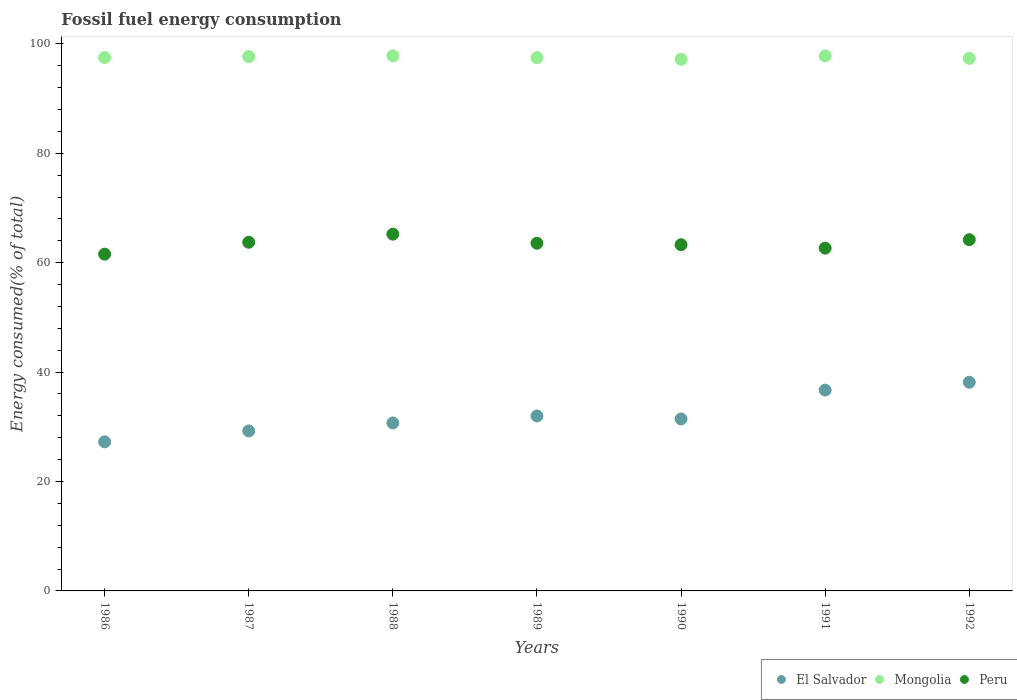How many different coloured dotlines are there?
Keep it short and to the point. 3. What is the percentage of energy consumed in El Salvador in 1988?
Offer a very short reply. 30.7. Across all years, what is the maximum percentage of energy consumed in El Salvador?
Provide a short and direct response. 38.14. Across all years, what is the minimum percentage of energy consumed in El Salvador?
Make the answer very short. 27.25. In which year was the percentage of energy consumed in Peru maximum?
Give a very brief answer. 1988. In which year was the percentage of energy consumed in Mongolia minimum?
Your response must be concise. 1990. What is the total percentage of energy consumed in El Salvador in the graph?
Your answer should be compact. 225.46. What is the difference between the percentage of energy consumed in Peru in 1986 and that in 1987?
Offer a terse response. -2.18. What is the difference between the percentage of energy consumed in El Salvador in 1991 and the percentage of energy consumed in Mongolia in 1989?
Offer a terse response. -60.77. What is the average percentage of energy consumed in El Salvador per year?
Make the answer very short. 32.21. In the year 1991, what is the difference between the percentage of energy consumed in Peru and percentage of energy consumed in El Salvador?
Offer a very short reply. 25.94. In how many years, is the percentage of energy consumed in Peru greater than 40 %?
Your answer should be very brief. 7. What is the ratio of the percentage of energy consumed in Peru in 1986 to that in 1990?
Give a very brief answer. 0.97. What is the difference between the highest and the second highest percentage of energy consumed in Peru?
Provide a succinct answer. 1.01. What is the difference between the highest and the lowest percentage of energy consumed in Peru?
Your answer should be very brief. 3.66. In how many years, is the percentage of energy consumed in El Salvador greater than the average percentage of energy consumed in El Salvador taken over all years?
Provide a short and direct response. 2. Is the sum of the percentage of energy consumed in El Salvador in 1988 and 1991 greater than the maximum percentage of energy consumed in Mongolia across all years?
Provide a succinct answer. No. How many dotlines are there?
Offer a terse response. 3. How many years are there in the graph?
Your response must be concise. 7. What is the difference between two consecutive major ticks on the Y-axis?
Your answer should be very brief. 20. Does the graph contain grids?
Keep it short and to the point. No. What is the title of the graph?
Offer a very short reply. Fossil fuel energy consumption. What is the label or title of the X-axis?
Provide a short and direct response. Years. What is the label or title of the Y-axis?
Your response must be concise. Energy consumed(% of total). What is the Energy consumed(% of total) of El Salvador in 1986?
Provide a succinct answer. 27.25. What is the Energy consumed(% of total) in Mongolia in 1986?
Keep it short and to the point. 97.5. What is the Energy consumed(% of total) of Peru in 1986?
Your response must be concise. 61.56. What is the Energy consumed(% of total) of El Salvador in 1987?
Your answer should be compact. 29.24. What is the Energy consumed(% of total) of Mongolia in 1987?
Your response must be concise. 97.67. What is the Energy consumed(% of total) in Peru in 1987?
Provide a short and direct response. 63.73. What is the Energy consumed(% of total) in El Salvador in 1988?
Give a very brief answer. 30.7. What is the Energy consumed(% of total) in Mongolia in 1988?
Keep it short and to the point. 97.8. What is the Energy consumed(% of total) in Peru in 1988?
Offer a very short reply. 65.22. What is the Energy consumed(% of total) in El Salvador in 1989?
Your answer should be compact. 31.98. What is the Energy consumed(% of total) in Mongolia in 1989?
Provide a succinct answer. 97.48. What is the Energy consumed(% of total) of Peru in 1989?
Make the answer very short. 63.55. What is the Energy consumed(% of total) of El Salvador in 1990?
Give a very brief answer. 31.44. What is the Energy consumed(% of total) of Mongolia in 1990?
Offer a terse response. 97.17. What is the Energy consumed(% of total) in Peru in 1990?
Give a very brief answer. 63.28. What is the Energy consumed(% of total) of El Salvador in 1991?
Give a very brief answer. 36.71. What is the Energy consumed(% of total) of Mongolia in 1991?
Provide a short and direct response. 97.8. What is the Energy consumed(% of total) of Peru in 1991?
Give a very brief answer. 62.65. What is the Energy consumed(% of total) in El Salvador in 1992?
Offer a very short reply. 38.14. What is the Energy consumed(% of total) of Mongolia in 1992?
Provide a short and direct response. 97.35. What is the Energy consumed(% of total) of Peru in 1992?
Ensure brevity in your answer.  64.2. Across all years, what is the maximum Energy consumed(% of total) in El Salvador?
Your answer should be very brief. 38.14. Across all years, what is the maximum Energy consumed(% of total) in Mongolia?
Give a very brief answer. 97.8. Across all years, what is the maximum Energy consumed(% of total) in Peru?
Offer a very short reply. 65.22. Across all years, what is the minimum Energy consumed(% of total) in El Salvador?
Your response must be concise. 27.25. Across all years, what is the minimum Energy consumed(% of total) of Mongolia?
Offer a very short reply. 97.17. Across all years, what is the minimum Energy consumed(% of total) in Peru?
Offer a terse response. 61.56. What is the total Energy consumed(% of total) of El Salvador in the graph?
Offer a very short reply. 225.46. What is the total Energy consumed(% of total) of Mongolia in the graph?
Make the answer very short. 682.76. What is the total Energy consumed(% of total) in Peru in the graph?
Offer a terse response. 444.19. What is the difference between the Energy consumed(% of total) of El Salvador in 1986 and that in 1987?
Your response must be concise. -1.99. What is the difference between the Energy consumed(% of total) of Mongolia in 1986 and that in 1987?
Provide a short and direct response. -0.17. What is the difference between the Energy consumed(% of total) in Peru in 1986 and that in 1987?
Your response must be concise. -2.18. What is the difference between the Energy consumed(% of total) of El Salvador in 1986 and that in 1988?
Give a very brief answer. -3.46. What is the difference between the Energy consumed(% of total) of Mongolia in 1986 and that in 1988?
Keep it short and to the point. -0.3. What is the difference between the Energy consumed(% of total) of Peru in 1986 and that in 1988?
Your answer should be compact. -3.66. What is the difference between the Energy consumed(% of total) of El Salvador in 1986 and that in 1989?
Offer a terse response. -4.73. What is the difference between the Energy consumed(% of total) of Mongolia in 1986 and that in 1989?
Ensure brevity in your answer.  0.02. What is the difference between the Energy consumed(% of total) in Peru in 1986 and that in 1989?
Offer a very short reply. -2. What is the difference between the Energy consumed(% of total) in El Salvador in 1986 and that in 1990?
Keep it short and to the point. -4.19. What is the difference between the Energy consumed(% of total) of Mongolia in 1986 and that in 1990?
Provide a succinct answer. 0.32. What is the difference between the Energy consumed(% of total) in Peru in 1986 and that in 1990?
Offer a very short reply. -1.72. What is the difference between the Energy consumed(% of total) in El Salvador in 1986 and that in 1991?
Your answer should be very brief. -9.46. What is the difference between the Energy consumed(% of total) of Mongolia in 1986 and that in 1991?
Offer a very short reply. -0.3. What is the difference between the Energy consumed(% of total) in Peru in 1986 and that in 1991?
Your response must be concise. -1.1. What is the difference between the Energy consumed(% of total) of El Salvador in 1986 and that in 1992?
Your response must be concise. -10.89. What is the difference between the Energy consumed(% of total) of Mongolia in 1986 and that in 1992?
Keep it short and to the point. 0.15. What is the difference between the Energy consumed(% of total) in Peru in 1986 and that in 1992?
Your response must be concise. -2.65. What is the difference between the Energy consumed(% of total) in El Salvador in 1987 and that in 1988?
Your response must be concise. -1.46. What is the difference between the Energy consumed(% of total) of Mongolia in 1987 and that in 1988?
Provide a short and direct response. -0.13. What is the difference between the Energy consumed(% of total) in Peru in 1987 and that in 1988?
Your answer should be compact. -1.48. What is the difference between the Energy consumed(% of total) in El Salvador in 1987 and that in 1989?
Make the answer very short. -2.74. What is the difference between the Energy consumed(% of total) of Mongolia in 1987 and that in 1989?
Provide a succinct answer. 0.19. What is the difference between the Energy consumed(% of total) of Peru in 1987 and that in 1989?
Provide a succinct answer. 0.18. What is the difference between the Energy consumed(% of total) of El Salvador in 1987 and that in 1990?
Make the answer very short. -2.19. What is the difference between the Energy consumed(% of total) of Mongolia in 1987 and that in 1990?
Ensure brevity in your answer.  0.5. What is the difference between the Energy consumed(% of total) of Peru in 1987 and that in 1990?
Offer a terse response. 0.45. What is the difference between the Energy consumed(% of total) of El Salvador in 1987 and that in 1991?
Your answer should be compact. -7.47. What is the difference between the Energy consumed(% of total) in Mongolia in 1987 and that in 1991?
Your answer should be compact. -0.13. What is the difference between the Energy consumed(% of total) in Peru in 1987 and that in 1991?
Your response must be concise. 1.08. What is the difference between the Energy consumed(% of total) of El Salvador in 1987 and that in 1992?
Your answer should be very brief. -8.9. What is the difference between the Energy consumed(% of total) of Mongolia in 1987 and that in 1992?
Your answer should be compact. 0.32. What is the difference between the Energy consumed(% of total) in Peru in 1987 and that in 1992?
Offer a very short reply. -0.47. What is the difference between the Energy consumed(% of total) in El Salvador in 1988 and that in 1989?
Provide a succinct answer. -1.27. What is the difference between the Energy consumed(% of total) of Mongolia in 1988 and that in 1989?
Offer a terse response. 0.32. What is the difference between the Energy consumed(% of total) in Peru in 1988 and that in 1989?
Keep it short and to the point. 1.66. What is the difference between the Energy consumed(% of total) in El Salvador in 1988 and that in 1990?
Your answer should be compact. -0.73. What is the difference between the Energy consumed(% of total) of Mongolia in 1988 and that in 1990?
Offer a terse response. 0.63. What is the difference between the Energy consumed(% of total) of Peru in 1988 and that in 1990?
Offer a terse response. 1.94. What is the difference between the Energy consumed(% of total) of El Salvador in 1988 and that in 1991?
Make the answer very short. -6. What is the difference between the Energy consumed(% of total) in Mongolia in 1988 and that in 1991?
Give a very brief answer. 0. What is the difference between the Energy consumed(% of total) of Peru in 1988 and that in 1991?
Your answer should be very brief. 2.56. What is the difference between the Energy consumed(% of total) of El Salvador in 1988 and that in 1992?
Provide a succinct answer. -7.44. What is the difference between the Energy consumed(% of total) of Mongolia in 1988 and that in 1992?
Offer a very short reply. 0.45. What is the difference between the Energy consumed(% of total) of Peru in 1988 and that in 1992?
Offer a very short reply. 1.01. What is the difference between the Energy consumed(% of total) in El Salvador in 1989 and that in 1990?
Ensure brevity in your answer.  0.54. What is the difference between the Energy consumed(% of total) in Mongolia in 1989 and that in 1990?
Offer a terse response. 0.31. What is the difference between the Energy consumed(% of total) in Peru in 1989 and that in 1990?
Offer a very short reply. 0.27. What is the difference between the Energy consumed(% of total) of El Salvador in 1989 and that in 1991?
Your response must be concise. -4.73. What is the difference between the Energy consumed(% of total) of Mongolia in 1989 and that in 1991?
Provide a short and direct response. -0.32. What is the difference between the Energy consumed(% of total) in Peru in 1989 and that in 1991?
Ensure brevity in your answer.  0.9. What is the difference between the Energy consumed(% of total) of El Salvador in 1989 and that in 1992?
Keep it short and to the point. -6.16. What is the difference between the Energy consumed(% of total) in Mongolia in 1989 and that in 1992?
Give a very brief answer. 0.13. What is the difference between the Energy consumed(% of total) in Peru in 1989 and that in 1992?
Make the answer very short. -0.65. What is the difference between the Energy consumed(% of total) of El Salvador in 1990 and that in 1991?
Offer a terse response. -5.27. What is the difference between the Energy consumed(% of total) in Mongolia in 1990 and that in 1991?
Make the answer very short. -0.63. What is the difference between the Energy consumed(% of total) of Peru in 1990 and that in 1991?
Offer a very short reply. 0.63. What is the difference between the Energy consumed(% of total) of El Salvador in 1990 and that in 1992?
Ensure brevity in your answer.  -6.7. What is the difference between the Energy consumed(% of total) in Mongolia in 1990 and that in 1992?
Keep it short and to the point. -0.18. What is the difference between the Energy consumed(% of total) of Peru in 1990 and that in 1992?
Offer a very short reply. -0.92. What is the difference between the Energy consumed(% of total) in El Salvador in 1991 and that in 1992?
Your answer should be very brief. -1.43. What is the difference between the Energy consumed(% of total) of Mongolia in 1991 and that in 1992?
Provide a succinct answer. 0.45. What is the difference between the Energy consumed(% of total) in Peru in 1991 and that in 1992?
Your answer should be very brief. -1.55. What is the difference between the Energy consumed(% of total) in El Salvador in 1986 and the Energy consumed(% of total) in Mongolia in 1987?
Your answer should be very brief. -70.42. What is the difference between the Energy consumed(% of total) in El Salvador in 1986 and the Energy consumed(% of total) in Peru in 1987?
Your answer should be very brief. -36.48. What is the difference between the Energy consumed(% of total) of Mongolia in 1986 and the Energy consumed(% of total) of Peru in 1987?
Make the answer very short. 33.76. What is the difference between the Energy consumed(% of total) of El Salvador in 1986 and the Energy consumed(% of total) of Mongolia in 1988?
Keep it short and to the point. -70.55. What is the difference between the Energy consumed(% of total) of El Salvador in 1986 and the Energy consumed(% of total) of Peru in 1988?
Offer a very short reply. -37.97. What is the difference between the Energy consumed(% of total) of Mongolia in 1986 and the Energy consumed(% of total) of Peru in 1988?
Ensure brevity in your answer.  32.28. What is the difference between the Energy consumed(% of total) of El Salvador in 1986 and the Energy consumed(% of total) of Mongolia in 1989?
Offer a terse response. -70.23. What is the difference between the Energy consumed(% of total) of El Salvador in 1986 and the Energy consumed(% of total) of Peru in 1989?
Make the answer very short. -36.3. What is the difference between the Energy consumed(% of total) of Mongolia in 1986 and the Energy consumed(% of total) of Peru in 1989?
Ensure brevity in your answer.  33.94. What is the difference between the Energy consumed(% of total) in El Salvador in 1986 and the Energy consumed(% of total) in Mongolia in 1990?
Ensure brevity in your answer.  -69.92. What is the difference between the Energy consumed(% of total) in El Salvador in 1986 and the Energy consumed(% of total) in Peru in 1990?
Ensure brevity in your answer.  -36.03. What is the difference between the Energy consumed(% of total) in Mongolia in 1986 and the Energy consumed(% of total) in Peru in 1990?
Keep it short and to the point. 34.22. What is the difference between the Energy consumed(% of total) in El Salvador in 1986 and the Energy consumed(% of total) in Mongolia in 1991?
Provide a succinct answer. -70.55. What is the difference between the Energy consumed(% of total) of El Salvador in 1986 and the Energy consumed(% of total) of Peru in 1991?
Provide a succinct answer. -35.4. What is the difference between the Energy consumed(% of total) in Mongolia in 1986 and the Energy consumed(% of total) in Peru in 1991?
Keep it short and to the point. 34.84. What is the difference between the Energy consumed(% of total) of El Salvador in 1986 and the Energy consumed(% of total) of Mongolia in 1992?
Ensure brevity in your answer.  -70.1. What is the difference between the Energy consumed(% of total) in El Salvador in 1986 and the Energy consumed(% of total) in Peru in 1992?
Give a very brief answer. -36.96. What is the difference between the Energy consumed(% of total) in Mongolia in 1986 and the Energy consumed(% of total) in Peru in 1992?
Offer a terse response. 33.29. What is the difference between the Energy consumed(% of total) in El Salvador in 1987 and the Energy consumed(% of total) in Mongolia in 1988?
Your answer should be compact. -68.56. What is the difference between the Energy consumed(% of total) in El Salvador in 1987 and the Energy consumed(% of total) in Peru in 1988?
Offer a very short reply. -35.97. What is the difference between the Energy consumed(% of total) of Mongolia in 1987 and the Energy consumed(% of total) of Peru in 1988?
Your response must be concise. 32.45. What is the difference between the Energy consumed(% of total) of El Salvador in 1987 and the Energy consumed(% of total) of Mongolia in 1989?
Provide a short and direct response. -68.24. What is the difference between the Energy consumed(% of total) in El Salvador in 1987 and the Energy consumed(% of total) in Peru in 1989?
Make the answer very short. -34.31. What is the difference between the Energy consumed(% of total) in Mongolia in 1987 and the Energy consumed(% of total) in Peru in 1989?
Provide a succinct answer. 34.11. What is the difference between the Energy consumed(% of total) of El Salvador in 1987 and the Energy consumed(% of total) of Mongolia in 1990?
Your answer should be compact. -67.93. What is the difference between the Energy consumed(% of total) in El Salvador in 1987 and the Energy consumed(% of total) in Peru in 1990?
Your answer should be compact. -34.04. What is the difference between the Energy consumed(% of total) of Mongolia in 1987 and the Energy consumed(% of total) of Peru in 1990?
Offer a terse response. 34.39. What is the difference between the Energy consumed(% of total) of El Salvador in 1987 and the Energy consumed(% of total) of Mongolia in 1991?
Your response must be concise. -68.56. What is the difference between the Energy consumed(% of total) in El Salvador in 1987 and the Energy consumed(% of total) in Peru in 1991?
Ensure brevity in your answer.  -33.41. What is the difference between the Energy consumed(% of total) of Mongolia in 1987 and the Energy consumed(% of total) of Peru in 1991?
Your answer should be compact. 35.02. What is the difference between the Energy consumed(% of total) in El Salvador in 1987 and the Energy consumed(% of total) in Mongolia in 1992?
Offer a very short reply. -68.11. What is the difference between the Energy consumed(% of total) in El Salvador in 1987 and the Energy consumed(% of total) in Peru in 1992?
Ensure brevity in your answer.  -34.96. What is the difference between the Energy consumed(% of total) in Mongolia in 1987 and the Energy consumed(% of total) in Peru in 1992?
Ensure brevity in your answer.  33.46. What is the difference between the Energy consumed(% of total) of El Salvador in 1988 and the Energy consumed(% of total) of Mongolia in 1989?
Your answer should be very brief. -66.78. What is the difference between the Energy consumed(% of total) in El Salvador in 1988 and the Energy consumed(% of total) in Peru in 1989?
Make the answer very short. -32.85. What is the difference between the Energy consumed(% of total) in Mongolia in 1988 and the Energy consumed(% of total) in Peru in 1989?
Provide a succinct answer. 34.25. What is the difference between the Energy consumed(% of total) of El Salvador in 1988 and the Energy consumed(% of total) of Mongolia in 1990?
Provide a short and direct response. -66.47. What is the difference between the Energy consumed(% of total) of El Salvador in 1988 and the Energy consumed(% of total) of Peru in 1990?
Provide a succinct answer. -32.58. What is the difference between the Energy consumed(% of total) of Mongolia in 1988 and the Energy consumed(% of total) of Peru in 1990?
Keep it short and to the point. 34.52. What is the difference between the Energy consumed(% of total) of El Salvador in 1988 and the Energy consumed(% of total) of Mongolia in 1991?
Provide a succinct answer. -67.09. What is the difference between the Energy consumed(% of total) in El Salvador in 1988 and the Energy consumed(% of total) in Peru in 1991?
Ensure brevity in your answer.  -31.95. What is the difference between the Energy consumed(% of total) of Mongolia in 1988 and the Energy consumed(% of total) of Peru in 1991?
Offer a terse response. 35.15. What is the difference between the Energy consumed(% of total) in El Salvador in 1988 and the Energy consumed(% of total) in Mongolia in 1992?
Your response must be concise. -66.65. What is the difference between the Energy consumed(% of total) in El Salvador in 1988 and the Energy consumed(% of total) in Peru in 1992?
Keep it short and to the point. -33.5. What is the difference between the Energy consumed(% of total) of Mongolia in 1988 and the Energy consumed(% of total) of Peru in 1992?
Ensure brevity in your answer.  33.59. What is the difference between the Energy consumed(% of total) of El Salvador in 1989 and the Energy consumed(% of total) of Mongolia in 1990?
Keep it short and to the point. -65.19. What is the difference between the Energy consumed(% of total) of El Salvador in 1989 and the Energy consumed(% of total) of Peru in 1990?
Your answer should be very brief. -31.3. What is the difference between the Energy consumed(% of total) of Mongolia in 1989 and the Energy consumed(% of total) of Peru in 1990?
Provide a short and direct response. 34.2. What is the difference between the Energy consumed(% of total) of El Salvador in 1989 and the Energy consumed(% of total) of Mongolia in 1991?
Your answer should be compact. -65.82. What is the difference between the Energy consumed(% of total) in El Salvador in 1989 and the Energy consumed(% of total) in Peru in 1991?
Provide a succinct answer. -30.68. What is the difference between the Energy consumed(% of total) in Mongolia in 1989 and the Energy consumed(% of total) in Peru in 1991?
Keep it short and to the point. 34.83. What is the difference between the Energy consumed(% of total) in El Salvador in 1989 and the Energy consumed(% of total) in Mongolia in 1992?
Your response must be concise. -65.37. What is the difference between the Energy consumed(% of total) of El Salvador in 1989 and the Energy consumed(% of total) of Peru in 1992?
Make the answer very short. -32.23. What is the difference between the Energy consumed(% of total) of Mongolia in 1989 and the Energy consumed(% of total) of Peru in 1992?
Make the answer very short. 33.27. What is the difference between the Energy consumed(% of total) of El Salvador in 1990 and the Energy consumed(% of total) of Mongolia in 1991?
Give a very brief answer. -66.36. What is the difference between the Energy consumed(% of total) in El Salvador in 1990 and the Energy consumed(% of total) in Peru in 1991?
Provide a succinct answer. -31.22. What is the difference between the Energy consumed(% of total) of Mongolia in 1990 and the Energy consumed(% of total) of Peru in 1991?
Offer a terse response. 34.52. What is the difference between the Energy consumed(% of total) in El Salvador in 1990 and the Energy consumed(% of total) in Mongolia in 1992?
Keep it short and to the point. -65.91. What is the difference between the Energy consumed(% of total) in El Salvador in 1990 and the Energy consumed(% of total) in Peru in 1992?
Your response must be concise. -32.77. What is the difference between the Energy consumed(% of total) of Mongolia in 1990 and the Energy consumed(% of total) of Peru in 1992?
Offer a terse response. 32.97. What is the difference between the Energy consumed(% of total) of El Salvador in 1991 and the Energy consumed(% of total) of Mongolia in 1992?
Keep it short and to the point. -60.64. What is the difference between the Energy consumed(% of total) of El Salvador in 1991 and the Energy consumed(% of total) of Peru in 1992?
Keep it short and to the point. -27.5. What is the difference between the Energy consumed(% of total) of Mongolia in 1991 and the Energy consumed(% of total) of Peru in 1992?
Provide a succinct answer. 33.59. What is the average Energy consumed(% of total) of El Salvador per year?
Your answer should be compact. 32.21. What is the average Energy consumed(% of total) in Mongolia per year?
Make the answer very short. 97.54. What is the average Energy consumed(% of total) in Peru per year?
Ensure brevity in your answer.  63.46. In the year 1986, what is the difference between the Energy consumed(% of total) in El Salvador and Energy consumed(% of total) in Mongolia?
Ensure brevity in your answer.  -70.25. In the year 1986, what is the difference between the Energy consumed(% of total) of El Salvador and Energy consumed(% of total) of Peru?
Ensure brevity in your answer.  -34.31. In the year 1986, what is the difference between the Energy consumed(% of total) in Mongolia and Energy consumed(% of total) in Peru?
Provide a succinct answer. 35.94. In the year 1987, what is the difference between the Energy consumed(% of total) of El Salvador and Energy consumed(% of total) of Mongolia?
Keep it short and to the point. -68.43. In the year 1987, what is the difference between the Energy consumed(% of total) of El Salvador and Energy consumed(% of total) of Peru?
Keep it short and to the point. -34.49. In the year 1987, what is the difference between the Energy consumed(% of total) in Mongolia and Energy consumed(% of total) in Peru?
Offer a terse response. 33.94. In the year 1988, what is the difference between the Energy consumed(% of total) of El Salvador and Energy consumed(% of total) of Mongolia?
Give a very brief answer. -67.1. In the year 1988, what is the difference between the Energy consumed(% of total) of El Salvador and Energy consumed(% of total) of Peru?
Provide a succinct answer. -34.51. In the year 1988, what is the difference between the Energy consumed(% of total) in Mongolia and Energy consumed(% of total) in Peru?
Provide a succinct answer. 32.58. In the year 1989, what is the difference between the Energy consumed(% of total) in El Salvador and Energy consumed(% of total) in Mongolia?
Provide a short and direct response. -65.5. In the year 1989, what is the difference between the Energy consumed(% of total) in El Salvador and Energy consumed(% of total) in Peru?
Provide a short and direct response. -31.58. In the year 1989, what is the difference between the Energy consumed(% of total) in Mongolia and Energy consumed(% of total) in Peru?
Provide a succinct answer. 33.93. In the year 1990, what is the difference between the Energy consumed(% of total) of El Salvador and Energy consumed(% of total) of Mongolia?
Provide a short and direct response. -65.74. In the year 1990, what is the difference between the Energy consumed(% of total) of El Salvador and Energy consumed(% of total) of Peru?
Offer a very short reply. -31.84. In the year 1990, what is the difference between the Energy consumed(% of total) of Mongolia and Energy consumed(% of total) of Peru?
Offer a very short reply. 33.89. In the year 1991, what is the difference between the Energy consumed(% of total) in El Salvador and Energy consumed(% of total) in Mongolia?
Give a very brief answer. -61.09. In the year 1991, what is the difference between the Energy consumed(% of total) of El Salvador and Energy consumed(% of total) of Peru?
Offer a terse response. -25.94. In the year 1991, what is the difference between the Energy consumed(% of total) in Mongolia and Energy consumed(% of total) in Peru?
Your response must be concise. 35.15. In the year 1992, what is the difference between the Energy consumed(% of total) of El Salvador and Energy consumed(% of total) of Mongolia?
Your response must be concise. -59.21. In the year 1992, what is the difference between the Energy consumed(% of total) of El Salvador and Energy consumed(% of total) of Peru?
Offer a very short reply. -26.06. In the year 1992, what is the difference between the Energy consumed(% of total) of Mongolia and Energy consumed(% of total) of Peru?
Make the answer very short. 33.14. What is the ratio of the Energy consumed(% of total) of El Salvador in 1986 to that in 1987?
Keep it short and to the point. 0.93. What is the ratio of the Energy consumed(% of total) in Mongolia in 1986 to that in 1987?
Offer a very short reply. 1. What is the ratio of the Energy consumed(% of total) of Peru in 1986 to that in 1987?
Your response must be concise. 0.97. What is the ratio of the Energy consumed(% of total) of El Salvador in 1986 to that in 1988?
Your response must be concise. 0.89. What is the ratio of the Energy consumed(% of total) of Peru in 1986 to that in 1988?
Your response must be concise. 0.94. What is the ratio of the Energy consumed(% of total) of El Salvador in 1986 to that in 1989?
Offer a terse response. 0.85. What is the ratio of the Energy consumed(% of total) of Peru in 1986 to that in 1989?
Offer a terse response. 0.97. What is the ratio of the Energy consumed(% of total) of El Salvador in 1986 to that in 1990?
Your answer should be very brief. 0.87. What is the ratio of the Energy consumed(% of total) of Peru in 1986 to that in 1990?
Provide a succinct answer. 0.97. What is the ratio of the Energy consumed(% of total) in El Salvador in 1986 to that in 1991?
Your answer should be very brief. 0.74. What is the ratio of the Energy consumed(% of total) in Mongolia in 1986 to that in 1991?
Offer a terse response. 1. What is the ratio of the Energy consumed(% of total) in Peru in 1986 to that in 1991?
Offer a very short reply. 0.98. What is the ratio of the Energy consumed(% of total) of El Salvador in 1986 to that in 1992?
Keep it short and to the point. 0.71. What is the ratio of the Energy consumed(% of total) of Mongolia in 1986 to that in 1992?
Make the answer very short. 1. What is the ratio of the Energy consumed(% of total) of Peru in 1986 to that in 1992?
Provide a short and direct response. 0.96. What is the ratio of the Energy consumed(% of total) in El Salvador in 1987 to that in 1988?
Provide a succinct answer. 0.95. What is the ratio of the Energy consumed(% of total) of Mongolia in 1987 to that in 1988?
Provide a short and direct response. 1. What is the ratio of the Energy consumed(% of total) in Peru in 1987 to that in 1988?
Ensure brevity in your answer.  0.98. What is the ratio of the Energy consumed(% of total) of El Salvador in 1987 to that in 1989?
Ensure brevity in your answer.  0.91. What is the ratio of the Energy consumed(% of total) of Peru in 1987 to that in 1989?
Keep it short and to the point. 1. What is the ratio of the Energy consumed(% of total) of El Salvador in 1987 to that in 1990?
Give a very brief answer. 0.93. What is the ratio of the Energy consumed(% of total) of Mongolia in 1987 to that in 1990?
Offer a terse response. 1.01. What is the ratio of the Energy consumed(% of total) in Peru in 1987 to that in 1990?
Provide a short and direct response. 1.01. What is the ratio of the Energy consumed(% of total) in El Salvador in 1987 to that in 1991?
Keep it short and to the point. 0.8. What is the ratio of the Energy consumed(% of total) of Peru in 1987 to that in 1991?
Provide a short and direct response. 1.02. What is the ratio of the Energy consumed(% of total) of El Salvador in 1987 to that in 1992?
Provide a succinct answer. 0.77. What is the ratio of the Energy consumed(% of total) of El Salvador in 1988 to that in 1989?
Ensure brevity in your answer.  0.96. What is the ratio of the Energy consumed(% of total) of Peru in 1988 to that in 1989?
Keep it short and to the point. 1.03. What is the ratio of the Energy consumed(% of total) of El Salvador in 1988 to that in 1990?
Your answer should be very brief. 0.98. What is the ratio of the Energy consumed(% of total) in Peru in 1988 to that in 1990?
Ensure brevity in your answer.  1.03. What is the ratio of the Energy consumed(% of total) in El Salvador in 1988 to that in 1991?
Offer a terse response. 0.84. What is the ratio of the Energy consumed(% of total) in Mongolia in 1988 to that in 1991?
Provide a short and direct response. 1. What is the ratio of the Energy consumed(% of total) in Peru in 1988 to that in 1991?
Offer a terse response. 1.04. What is the ratio of the Energy consumed(% of total) of El Salvador in 1988 to that in 1992?
Keep it short and to the point. 0.81. What is the ratio of the Energy consumed(% of total) in Peru in 1988 to that in 1992?
Your answer should be compact. 1.02. What is the ratio of the Energy consumed(% of total) in El Salvador in 1989 to that in 1990?
Give a very brief answer. 1.02. What is the ratio of the Energy consumed(% of total) of Mongolia in 1989 to that in 1990?
Ensure brevity in your answer.  1. What is the ratio of the Energy consumed(% of total) in El Salvador in 1989 to that in 1991?
Ensure brevity in your answer.  0.87. What is the ratio of the Energy consumed(% of total) of Mongolia in 1989 to that in 1991?
Ensure brevity in your answer.  1. What is the ratio of the Energy consumed(% of total) of Peru in 1989 to that in 1991?
Keep it short and to the point. 1.01. What is the ratio of the Energy consumed(% of total) of El Salvador in 1989 to that in 1992?
Offer a terse response. 0.84. What is the ratio of the Energy consumed(% of total) of Peru in 1989 to that in 1992?
Your answer should be compact. 0.99. What is the ratio of the Energy consumed(% of total) in El Salvador in 1990 to that in 1991?
Offer a very short reply. 0.86. What is the ratio of the Energy consumed(% of total) in Mongolia in 1990 to that in 1991?
Your answer should be compact. 0.99. What is the ratio of the Energy consumed(% of total) of Peru in 1990 to that in 1991?
Give a very brief answer. 1.01. What is the ratio of the Energy consumed(% of total) of El Salvador in 1990 to that in 1992?
Offer a very short reply. 0.82. What is the ratio of the Energy consumed(% of total) in Mongolia in 1990 to that in 1992?
Your answer should be compact. 1. What is the ratio of the Energy consumed(% of total) of Peru in 1990 to that in 1992?
Keep it short and to the point. 0.99. What is the ratio of the Energy consumed(% of total) in El Salvador in 1991 to that in 1992?
Offer a very short reply. 0.96. What is the ratio of the Energy consumed(% of total) of Peru in 1991 to that in 1992?
Provide a succinct answer. 0.98. What is the difference between the highest and the second highest Energy consumed(% of total) of El Salvador?
Make the answer very short. 1.43. What is the difference between the highest and the second highest Energy consumed(% of total) in Mongolia?
Your response must be concise. 0. What is the difference between the highest and the second highest Energy consumed(% of total) in Peru?
Provide a short and direct response. 1.01. What is the difference between the highest and the lowest Energy consumed(% of total) in El Salvador?
Provide a short and direct response. 10.89. What is the difference between the highest and the lowest Energy consumed(% of total) in Mongolia?
Your response must be concise. 0.63. What is the difference between the highest and the lowest Energy consumed(% of total) in Peru?
Provide a succinct answer. 3.66. 